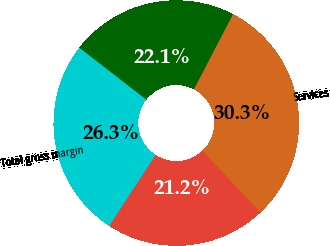Convert chart to OTSL. <chart><loc_0><loc_0><loc_500><loc_500><pie_chart><fcel>Product<fcel>Services<fcel>Ratable product and services<fcel>Total gross margin<nl><fcel>21.23%<fcel>30.34%<fcel>22.14%<fcel>26.29%<nl></chart> 